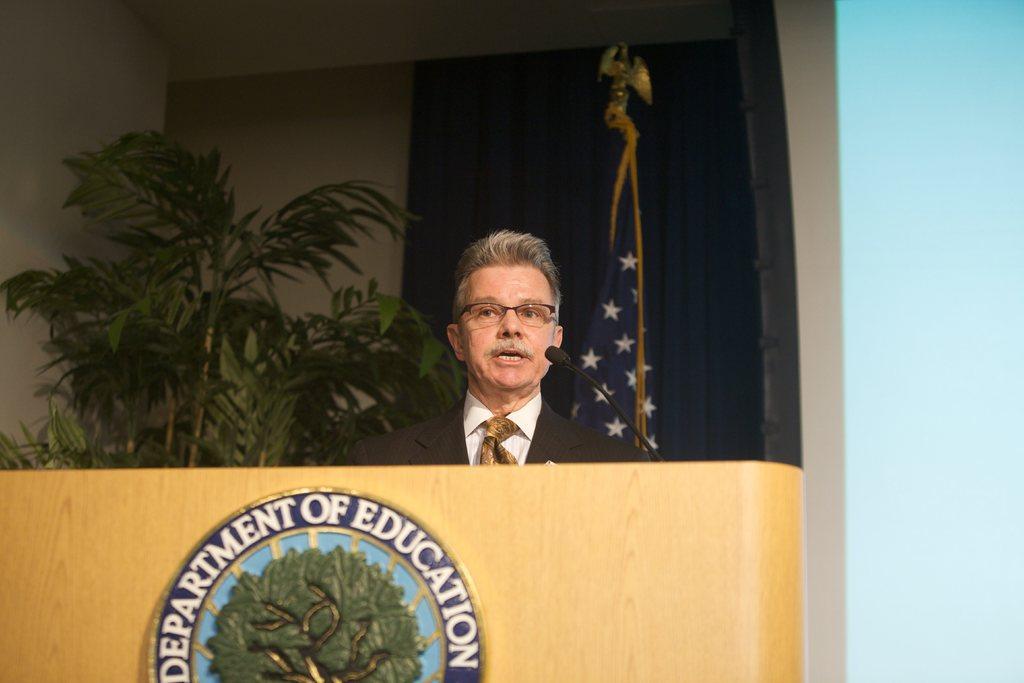Can you describe this image briefly? In this image we can see a person speaking into a microphone. There is a curtain in the image. There is a plant in the image. There is some text and a logo on the podium in the image. 